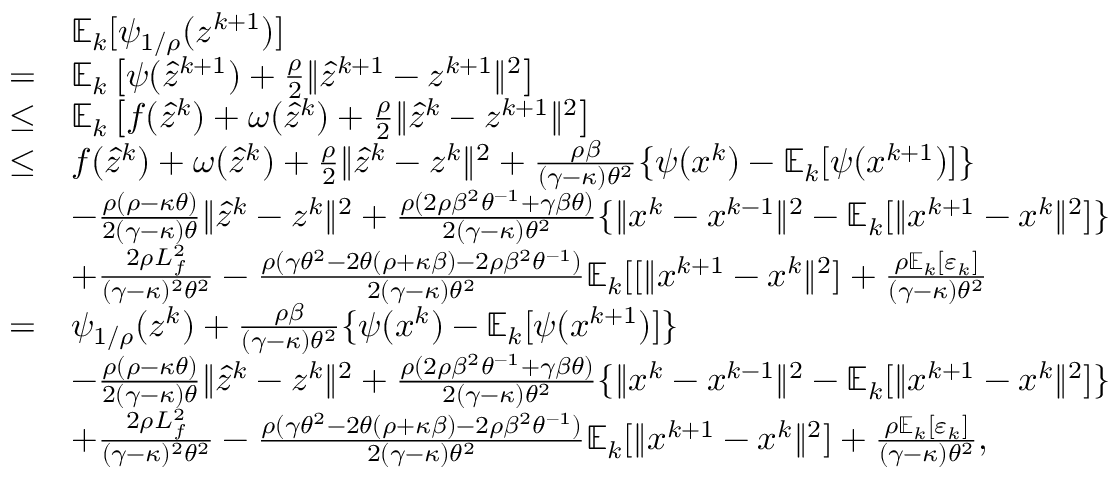Convert formula to latex. <formula><loc_0><loc_0><loc_500><loc_500>\begin{array} { r l } & { \mathbb { E } _ { k } [ \psi _ { 1 / \rho } ( z ^ { k + 1 } ) ] } \\ { = } & { \mathbb { E } _ { k } \left [ \psi ( \hat { z } ^ { k + 1 } ) + \frac { \rho } { 2 } \| \hat { z } ^ { k + 1 } - z ^ { k + 1 } \| ^ { 2 } \right ] } \\ { \leq } & { \mathbb { E } _ { k } \left [ f ( \hat { z } ^ { k } ) + \omega ( \hat { z } ^ { k } ) + \frac { \rho } { 2 } \| \hat { z } ^ { k } - z ^ { k + 1 } \| ^ { 2 } \right ] } \\ { \leq } & { f ( \hat { z } ^ { k } ) + \omega ( \hat { z } ^ { k } ) + \frac { \rho } { 2 } \| \hat { z } ^ { k } - z ^ { k } \| ^ { 2 } + \frac { \rho \beta } { ( \gamma - \kappa ) \theta ^ { 2 } } \{ \psi ( x ^ { k } ) - \mathbb { E } _ { k } [ \psi ( x ^ { k + 1 } ) ] \} } \\ & { - \frac { \rho ( \rho - \kappa \theta ) } { 2 ( \gamma - \kappa ) \theta } \| \hat { z } ^ { k } - z ^ { k } \| ^ { 2 } + \frac { \rho ( 2 \rho \beta ^ { 2 } \theta ^ { - 1 } + \gamma \beta \theta ) } { 2 ( \gamma - \kappa ) \theta ^ { 2 } } \{ \| x ^ { k } - x ^ { k - 1 } \| ^ { 2 } - \mathbb { E } _ { k } [ \| x ^ { k + 1 } - x ^ { k } \| ^ { 2 } ] \} } \\ & { + \frac { 2 \rho L _ { f } ^ { 2 } } { ( \gamma - \kappa ) ^ { 2 } \theta ^ { 2 } } - \frac { \rho ( \gamma \theta ^ { 2 } - 2 \theta ( \rho + \kappa \beta ) - 2 \rho \beta ^ { 2 } \theta ^ { - 1 } ) } { 2 ( \gamma - \kappa ) \theta ^ { 2 } } \mathbb { E } _ { k } [ [ \| x ^ { k + 1 } - x ^ { k } \| ^ { 2 } ] + \frac { \rho \mathbb { E } _ { k } [ \varepsilon _ { k } ] } { ( \gamma - \kappa ) \theta ^ { 2 } } } \\ { = } & { \psi _ { 1 / \rho } ( z ^ { k } ) + \frac { \rho \beta } { ( \gamma - \kappa ) \theta ^ { 2 } } \{ \psi ( x ^ { k } ) - \mathbb { E } _ { k } [ \psi ( x ^ { k + 1 } ) ] \} } \\ & { - \frac { \rho ( \rho - \kappa \theta ) } { 2 ( \gamma - \kappa ) \theta } \| \hat { z } ^ { k } - z ^ { k } \| ^ { 2 } + \frac { \rho ( 2 \rho \beta ^ { 2 } \theta ^ { - 1 } + \gamma \beta \theta ) } { 2 ( \gamma - \kappa ) \theta ^ { 2 } } \{ \| x ^ { k } - x ^ { k - 1 } \| ^ { 2 } - \mathbb { E } _ { k } [ \| x ^ { k + 1 } - x ^ { k } \| ^ { 2 } ] \} } \\ & { + \frac { 2 \rho L _ { f } ^ { 2 } } { ( \gamma - \kappa ) ^ { 2 } \theta ^ { 2 } } - \frac { \rho ( \gamma \theta ^ { 2 } - 2 \theta ( \rho + \kappa \beta ) - 2 \rho \beta ^ { 2 } \theta ^ { - 1 } ) } { 2 ( \gamma - \kappa ) \theta ^ { 2 } } \mathbb { E } _ { k } [ \| x ^ { k + 1 } - x ^ { k } \| ^ { 2 } ] + \frac { \rho \mathbb { E } _ { k } [ \varepsilon _ { k } ] } { ( \gamma - \kappa ) \theta ^ { 2 } } , } \end{array}</formula> 